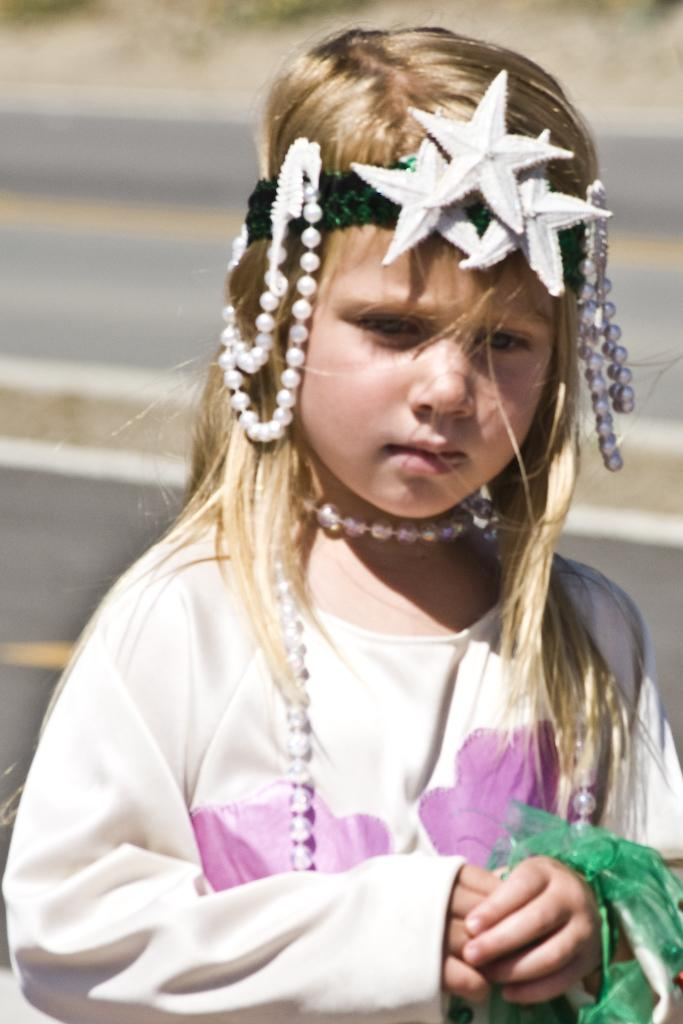Who is the main subject in the image? There is a girl in the image. What is the girl wearing in the image? The girl is wearing ornaments and a band on her head. She is also wearing a white color dress. What type of grape can be seen hanging from the band on the girl's head? There is no grape present in the image, and therefore no such object can be observed hanging from the band on the girl's head. 